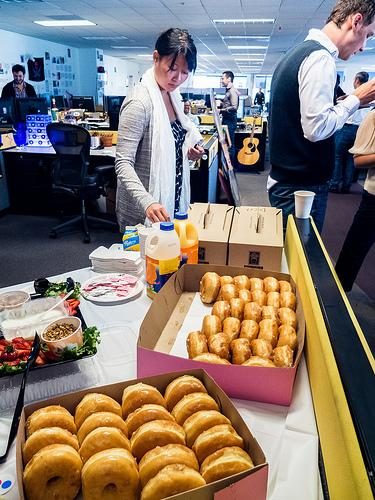Describe the scene in the image with a focus on the people present. In the image, a woman with black hair and a man wearing a dark vest are in an office setting with other people around. Narrate the picture's contents, focusing on the actions of the individuals present. A black-haired woman and a man wearing a dark vest are interacting in an office setting with food and drinks, such as doughnuts and orange juice. Outline a scene from the image, highlighting interactions between people. In an office, a woman wearing a white scarf is looking at a jug of orange juice while a man in a black vest observes her. Describe the location where the image is taken and the main activities happening. The image is set in an office with people interacting, surrounded by various items like doughnuts, orange juice, a guitar, and a tablecloth. Briefly describe the main color scheme in the image, along with the items that contribute to it. The image displays a pink doughnut box, white napkins, two bottles of orange juice, and people dressed in various colors, creating a vibrant color scheme. Provide an overview of the elements that contribute to the image's ambiance. The image creates a social atmosphere of people in an office space, surrounded by food and drinks like doughnuts, orange juice, and napkins. Provide a brief description of the image, focusing on the most noticeable items. The image prominently features a pink box of doughnuts, two bottles of orange juice, a guitar, and people in an office. Mention the primary object in the image and its key attribute. The main object in the image is a pink doughnut box filled with glazed doughnuts. Examine the image and describe the most appealing and/or appetizing aspects. A pink box filled with golden brown glazed doughnuts and two bottles of refreshing orange juice are attractively featured in the image. Discuss one central theme of the image and provide examples. One central theme of the image is nourishment, with a focus on items like the pink doughnut box, two bottles of orange juice, and a stack of white napkins. 